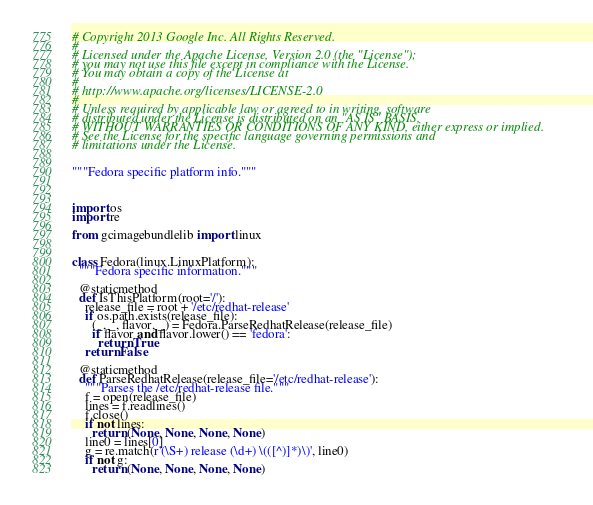<code> <loc_0><loc_0><loc_500><loc_500><_Python_># Copyright 2013 Google Inc. All Rights Reserved.
#
# Licensed under the Apache License, Version 2.0 (the "License");
# you may not use this file except in compliance with the License.
# You may obtain a copy of the License at
#
# http://www.apache.org/licenses/LICENSE-2.0
#
# Unless required by applicable law or agreed to in writing, software
# distributed under the License is distributed on an "AS IS" BASIS,
# WITHOUT WARRANTIES OR CONDITIONS OF ANY KIND, either express or implied.
# See the License for the specific language governing permissions and
# limitations under the License.


"""Fedora specific platform info."""



import os
import re

from gcimagebundlelib import linux


class Fedora(linux.LinuxPlatform):
  """Fedora specific information."""

  @staticmethod
  def IsThisPlatform(root='/'):
    release_file = root + '/etc/redhat-release'
    if os.path.exists(release_file):
      (_, _, flavor, _) = Fedora.ParseRedhatRelease(release_file)
      if flavor and flavor.lower() == 'fedora':
        return True
    return False

  @staticmethod
  def ParseRedhatRelease(release_file='/etc/redhat-release'):
    """Parses the /etc/redhat-release file."""
    f = open(release_file)
    lines = f.readlines()
    f.close()
    if not lines:
      return (None, None, None, None)
    line0 = lines[0]
    g = re.match(r'(\S+) release (\d+) \(([^)]*)\)', line0)
    if not g:
      return (None, None, None, None)</code> 